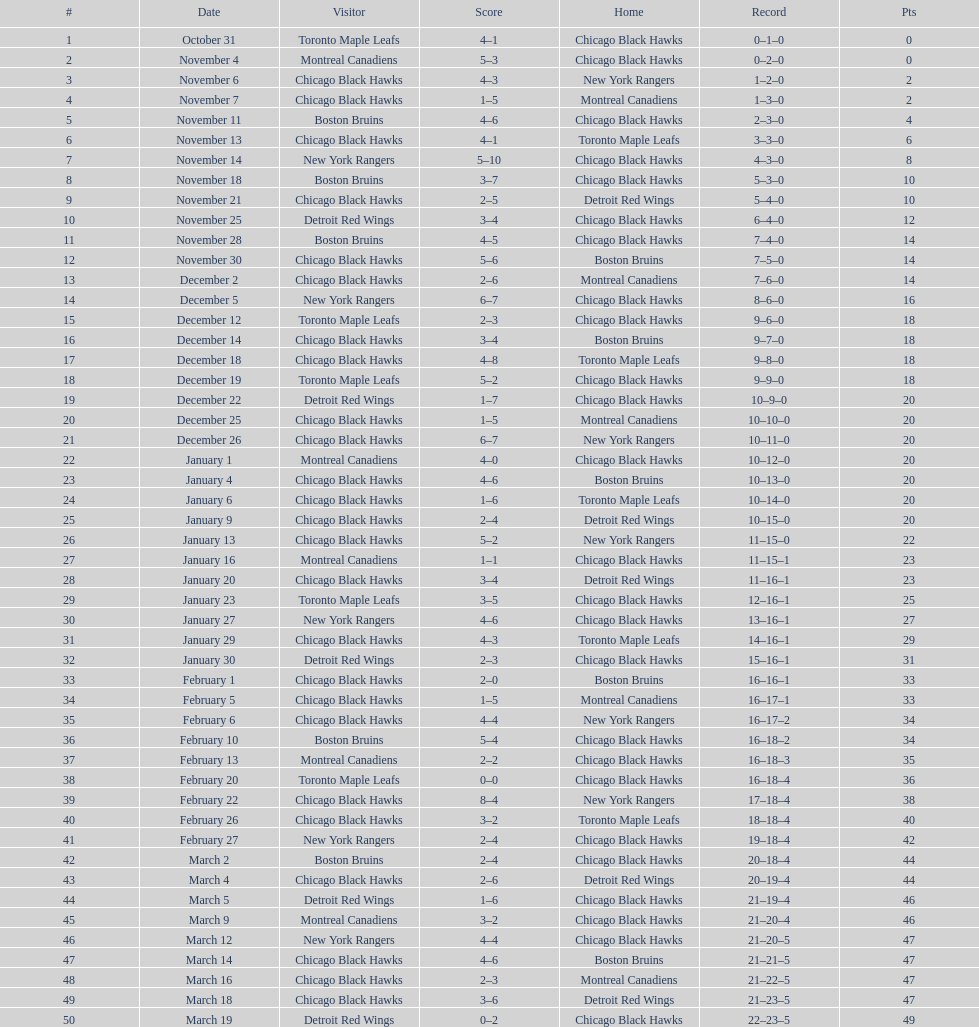Over what period does one season last, beginning with the first game and concluding with the last? 5 months. 